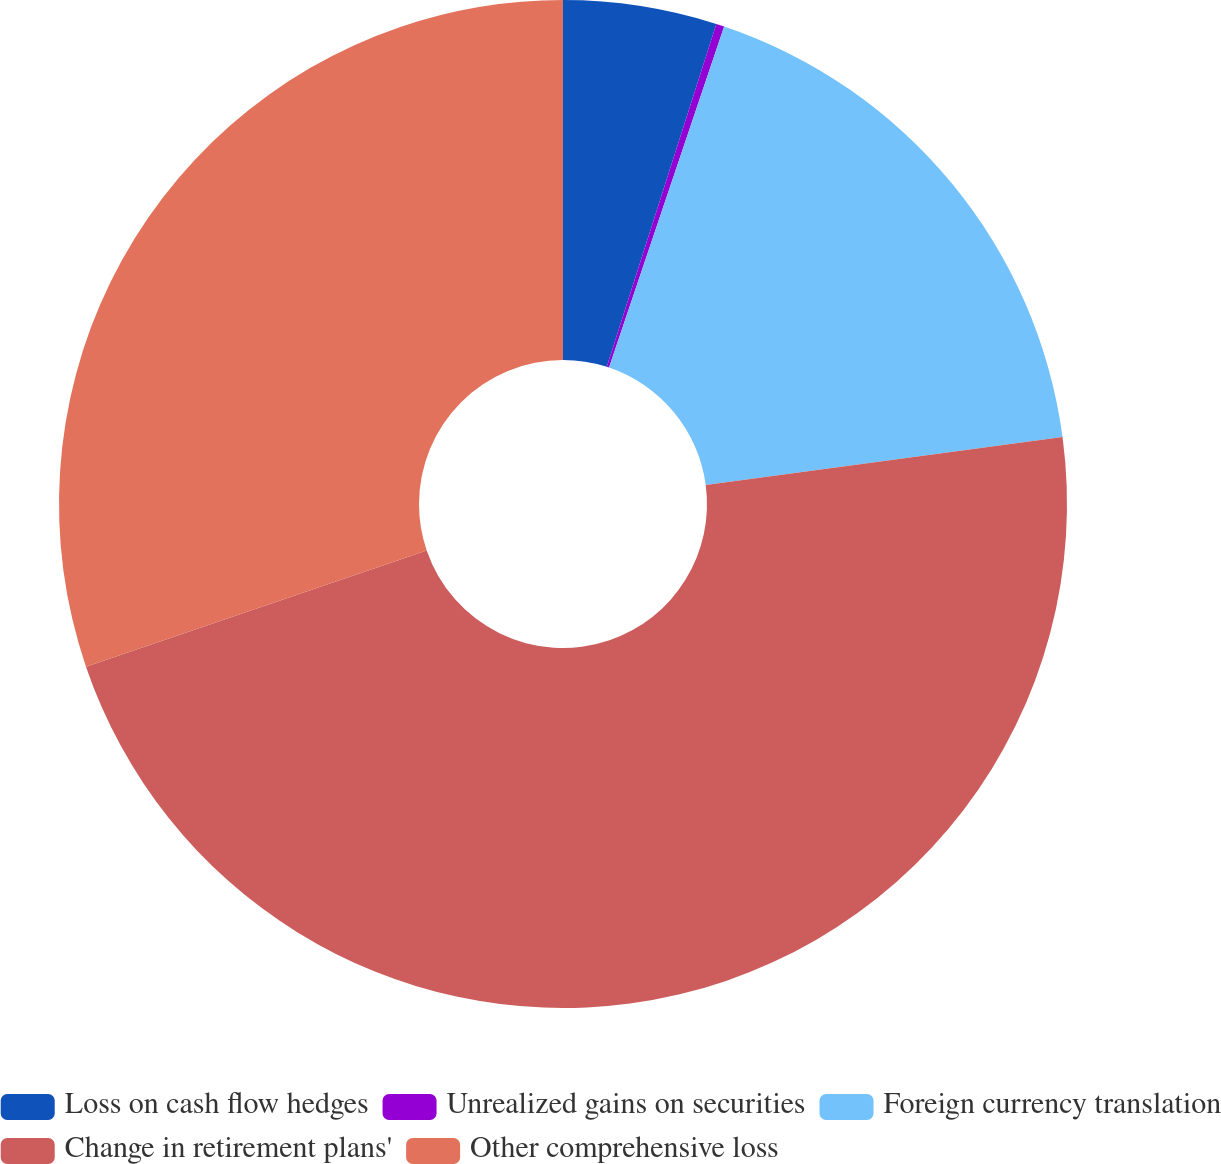Convert chart. <chart><loc_0><loc_0><loc_500><loc_500><pie_chart><fcel>Loss on cash flow hedges<fcel>Unrealized gains on securities<fcel>Foreign currency translation<fcel>Change in retirement plans'<fcel>Other comprehensive loss<nl><fcel>4.92%<fcel>0.26%<fcel>17.7%<fcel>46.89%<fcel>30.23%<nl></chart> 